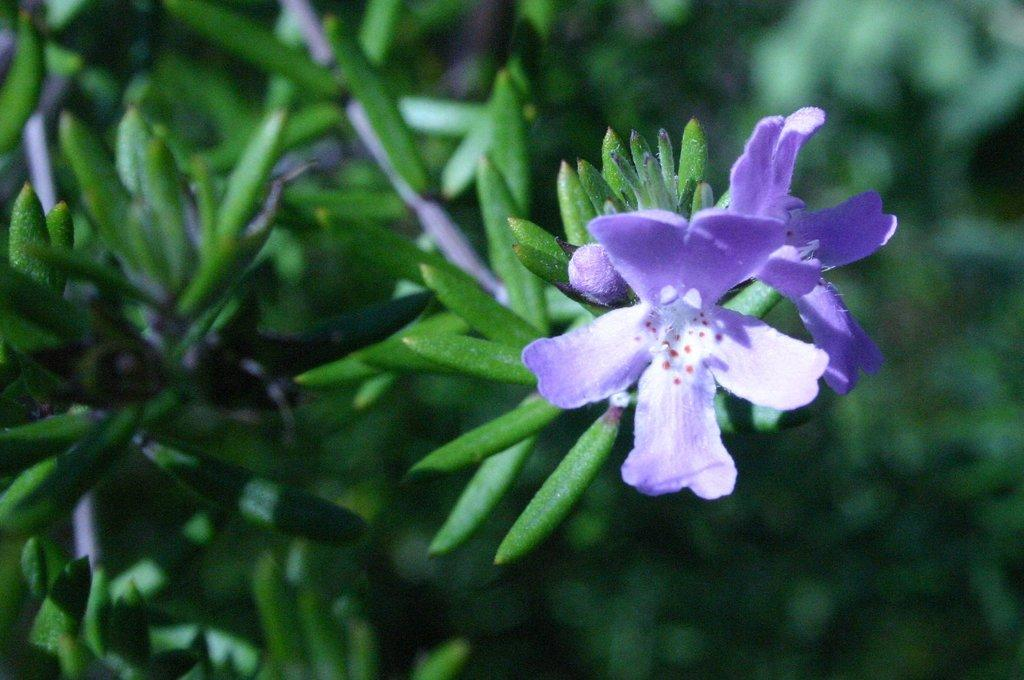What type of living organisms can be seen in the image? Plants can be seen in the image. What color are the flowers on the plants in the image? The flowers on the plants in the image are violet. What type of cushion is being used by the authority figure in the image? There is no authority figure or cushion present in the image. 